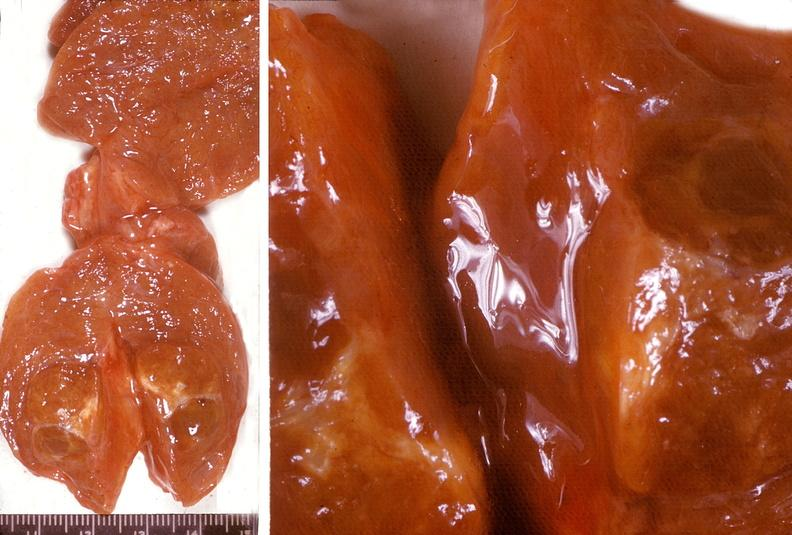does adenoma show thyroid, nodular colloid goiter?
Answer the question using a single word or phrase. No 